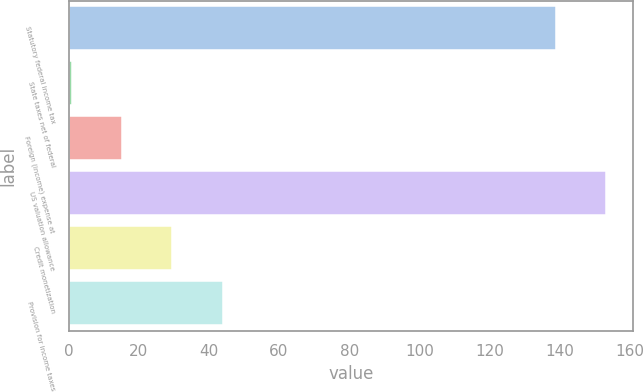Convert chart. <chart><loc_0><loc_0><loc_500><loc_500><bar_chart><fcel>Statutory federal income tax<fcel>State taxes net of federal<fcel>Foreign (income) expense at<fcel>US valuation allowance<fcel>Credit monetization<fcel>Provision for income taxes<nl><fcel>139<fcel>1<fcel>15.3<fcel>153.3<fcel>29.6<fcel>43.9<nl></chart> 